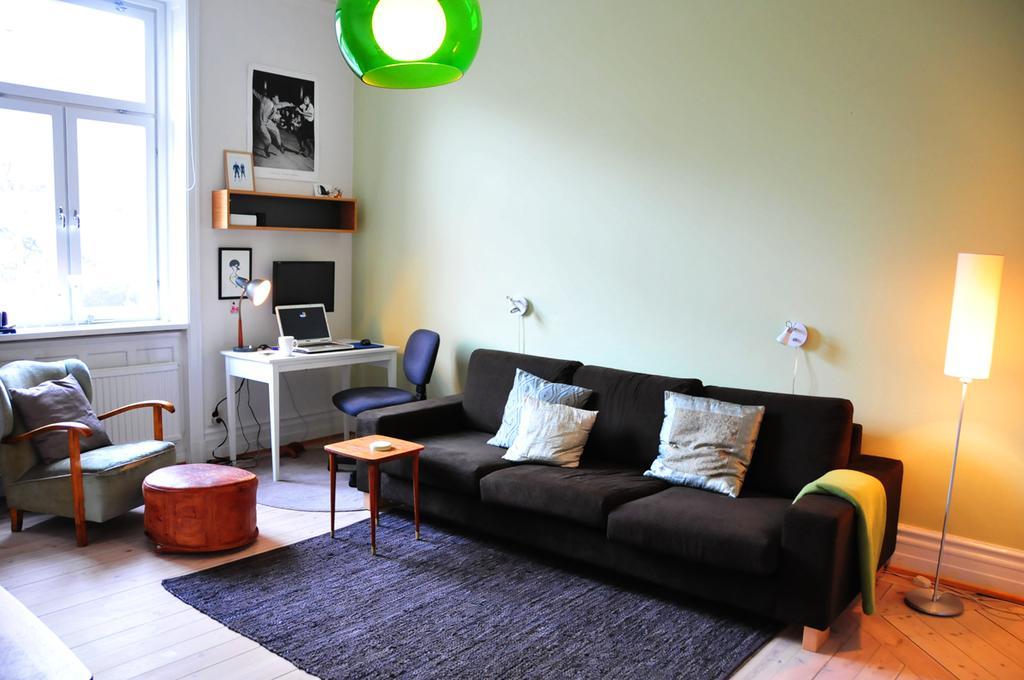How would you summarize this image in a sentence or two? In the left top, a window is visible. In the middle and bottom, chairs, stool, table and a sofa is visible on which cushions are kept. A table on which laptop, cup and a lamp is there. background wall is light green in color. On the top middle, a light is fixed. In the left a photo is there on the wall. This image is taken inside a house. 